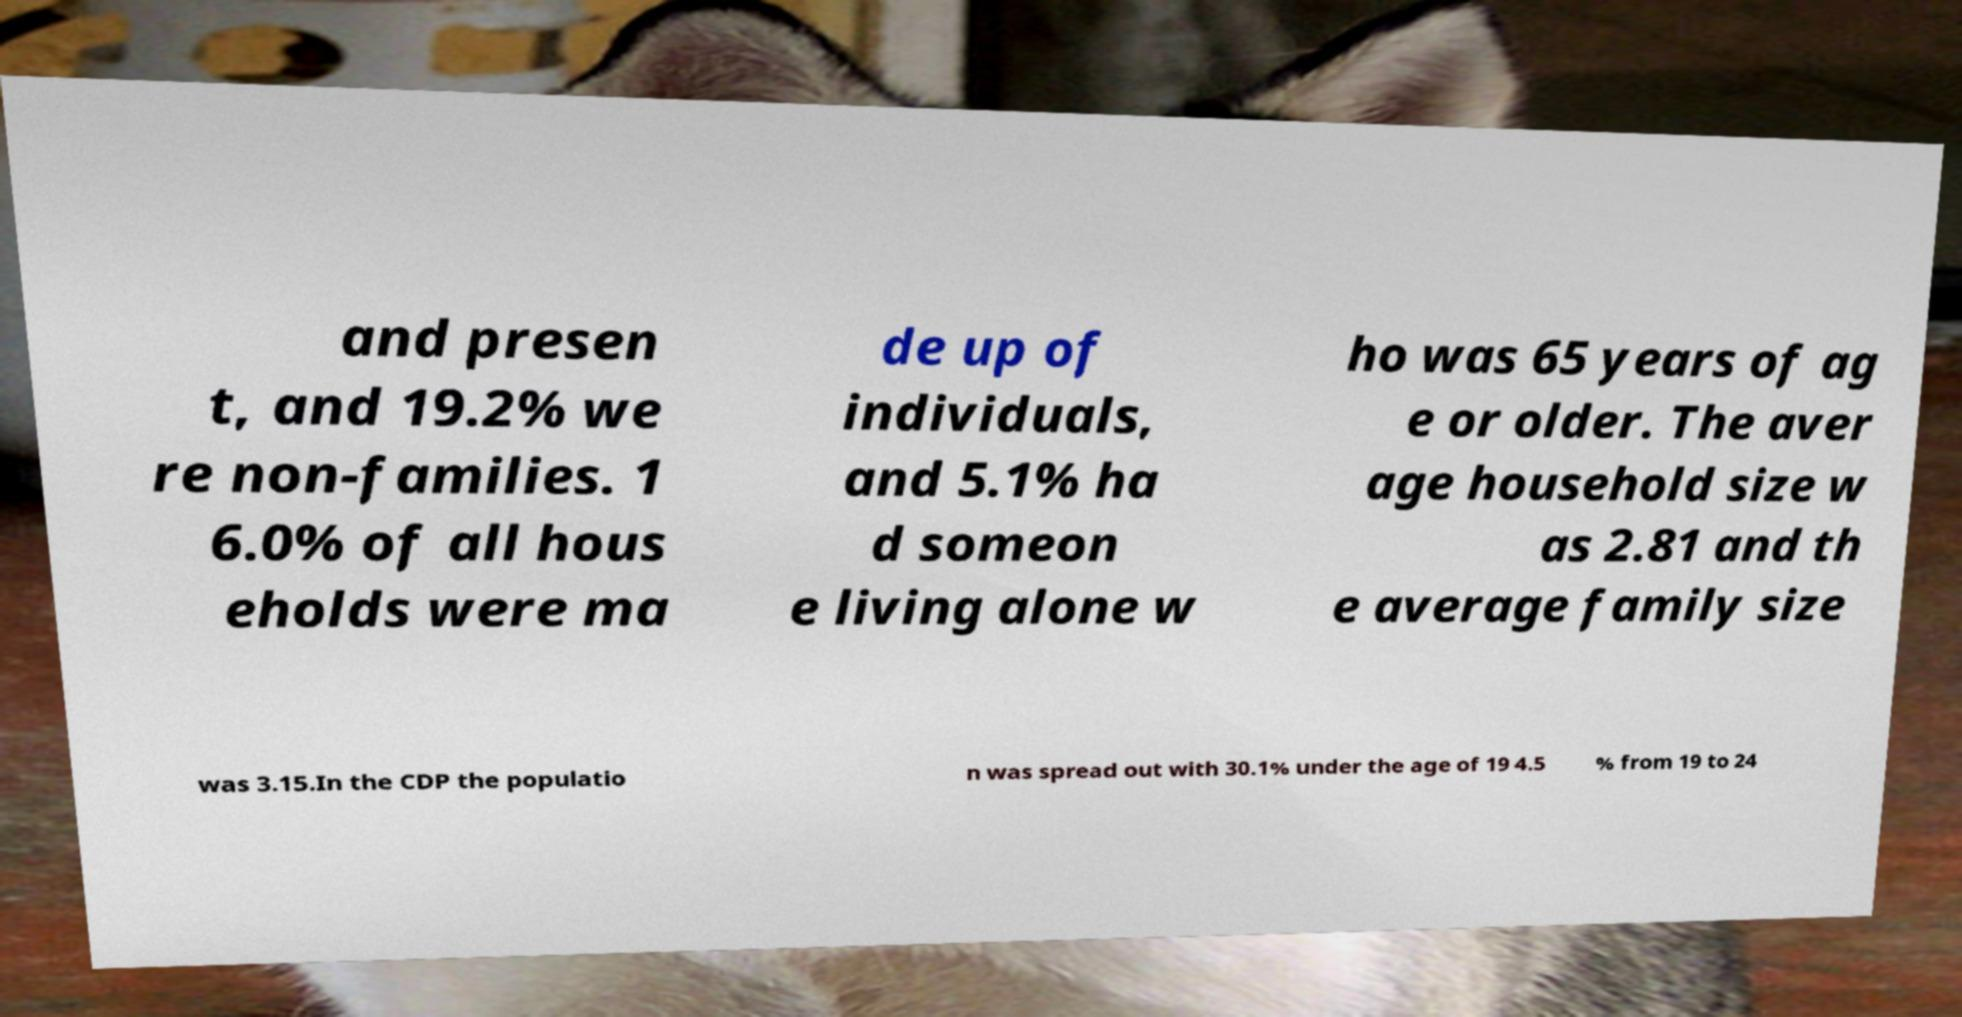What messages or text are displayed in this image? I need them in a readable, typed format. and presen t, and 19.2% we re non-families. 1 6.0% of all hous eholds were ma de up of individuals, and 5.1% ha d someon e living alone w ho was 65 years of ag e or older. The aver age household size w as 2.81 and th e average family size was 3.15.In the CDP the populatio n was spread out with 30.1% under the age of 19 4.5 % from 19 to 24 